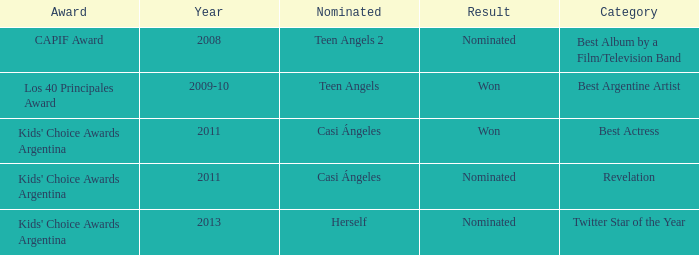What year was Teen Angels 2 nominated? 2008.0. 